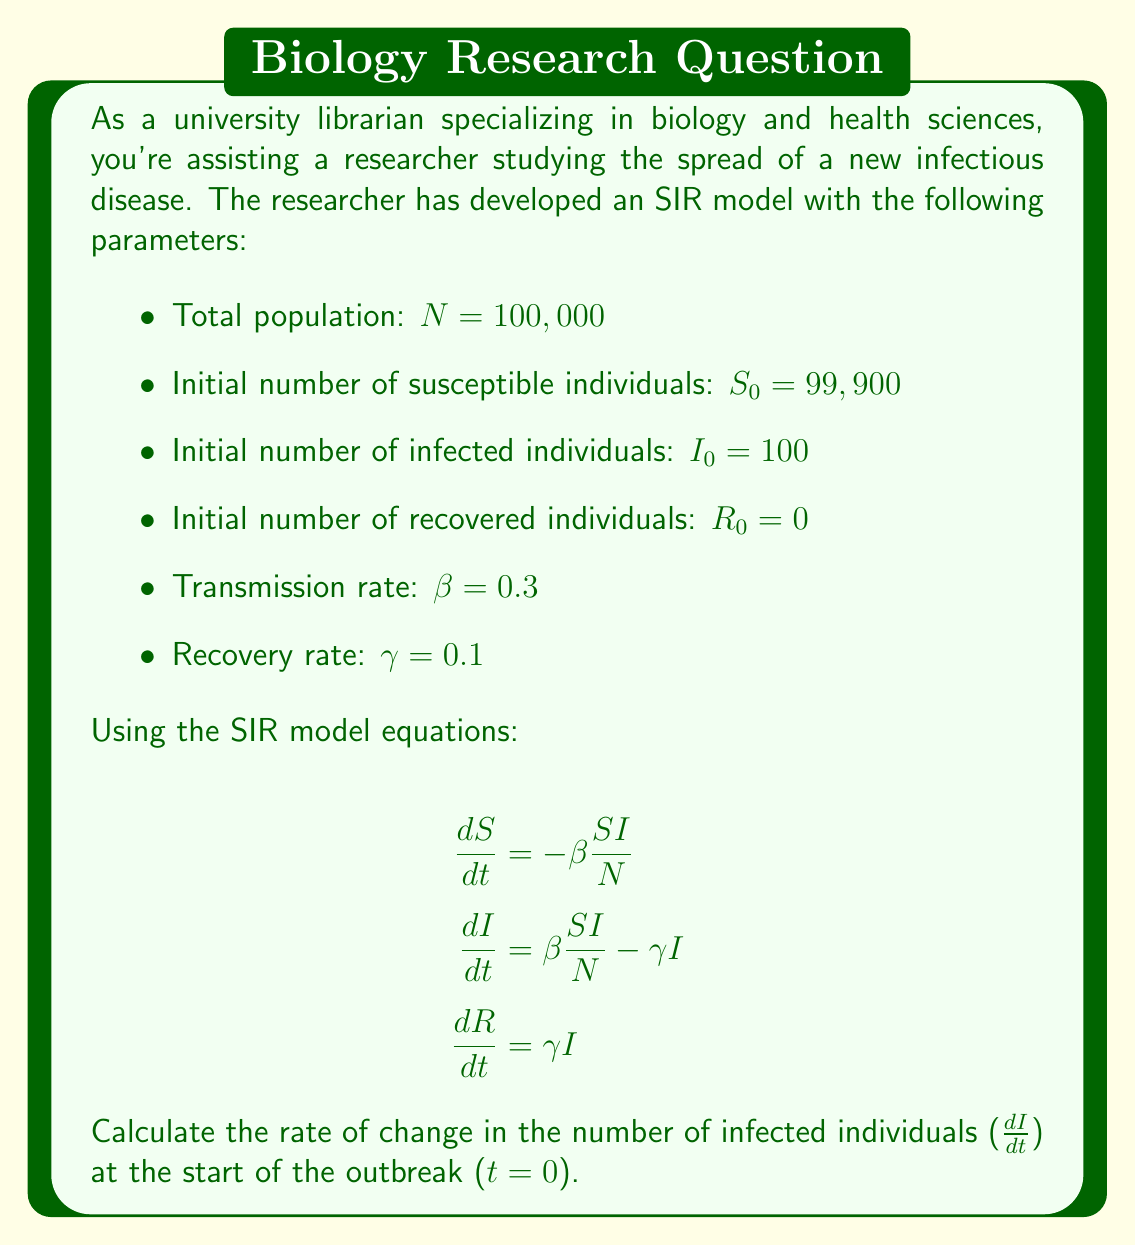What is the answer to this math problem? To solve this problem, we need to use the equation for the rate of change in the number of infected individuals:

$$\frac{dI}{dt} = \beta \frac{SI}{N} - \gamma I$$

We'll substitute the given values into this equation:

1. $\beta = 0.3$
2. $S = S_0 = 99,900$ (initial number of susceptible individuals)
3. $I = I_0 = 100$ (initial number of infected individuals)
4. $N = 100,000$ (total population)
5. $\gamma = 0.1$

Now, let's substitute these values into the equation:

$$\frac{dI}{dt} = 0.3 \cdot \frac{99,900 \cdot 100}{100,000} - 0.1 \cdot 100$$

Let's solve this step by step:

1. Calculate $\frac{SI}{N}$:
   $$\frac{99,900 \cdot 100}{100,000} = 99.9$$

2. Multiply by $\beta$:
   $$0.3 \cdot 99.9 = 29.97$$

3. Calculate $\gamma I$:
   $$0.1 \cdot 100 = 10$$

4. Subtract $\gamma I$ from $\beta \frac{SI}{N}$:
   $$29.97 - 10 = 19.97$$

Therefore, the rate of change in the number of infected individuals at the start of the outbreak is 19.97 individuals per unit time.
Answer: $\frac{dI}{dt} = 19.97$ individuals per unit time 